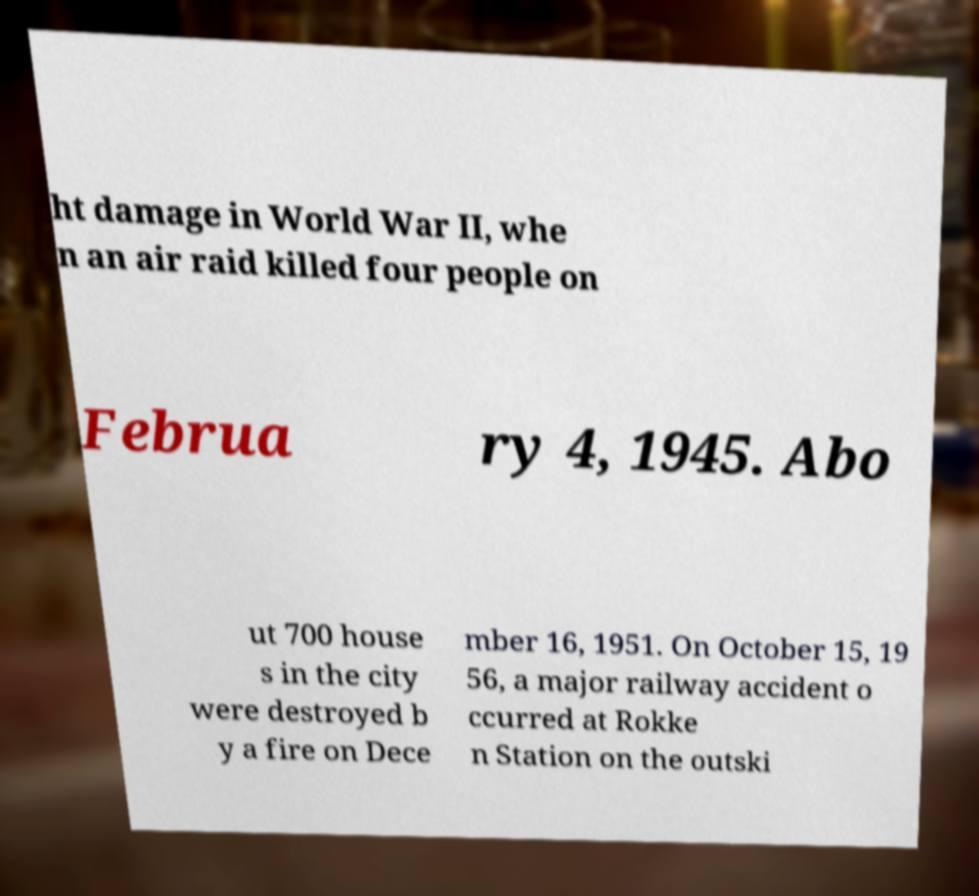Can you accurately transcribe the text from the provided image for me? ht damage in World War II, whe n an air raid killed four people on Februa ry 4, 1945. Abo ut 700 house s in the city were destroyed b y a fire on Dece mber 16, 1951. On October 15, 19 56, a major railway accident o ccurred at Rokke n Station on the outski 